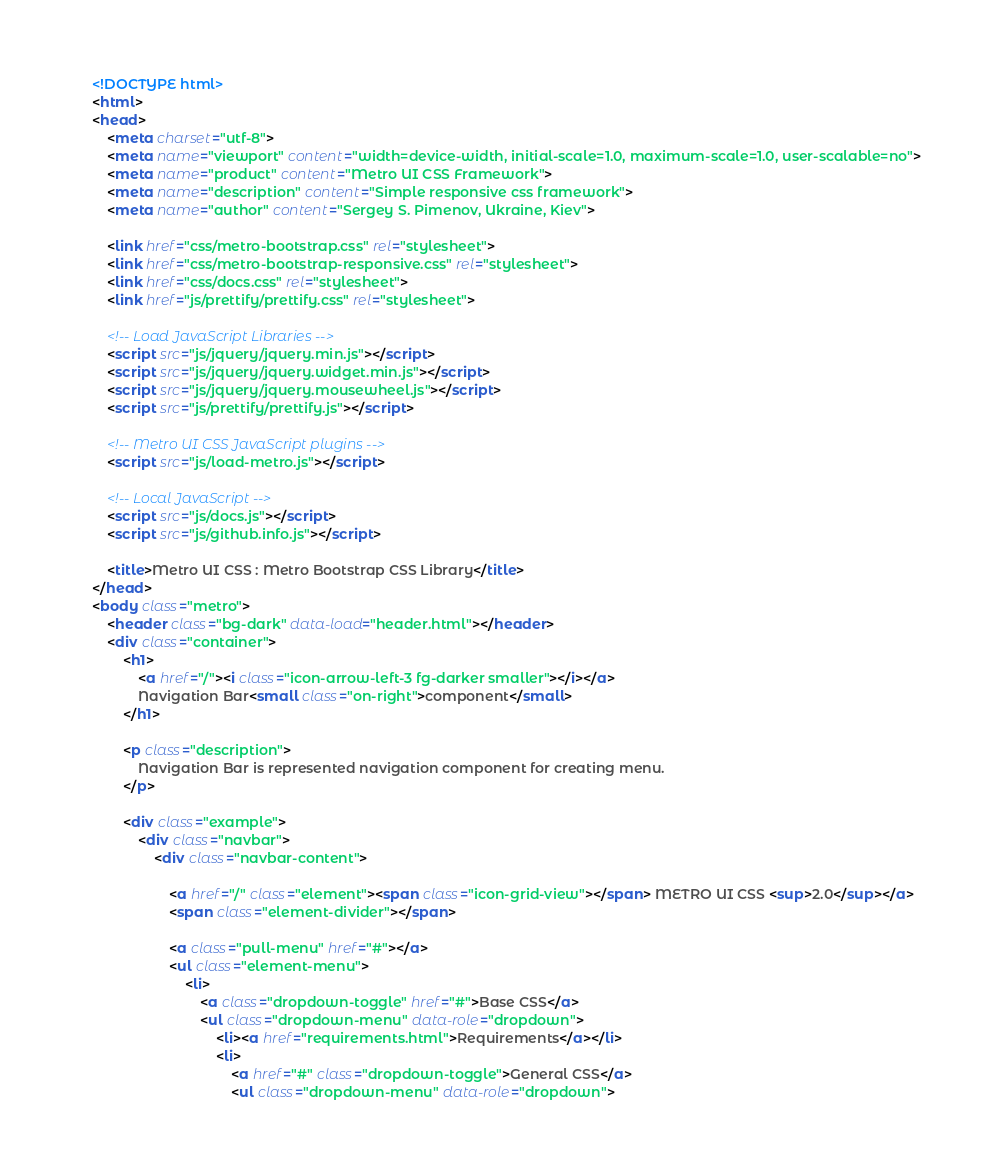<code> <loc_0><loc_0><loc_500><loc_500><_HTML_><!DOCTYPE html>
<html>
<head>
    <meta charset="utf-8">
    <meta name="viewport" content="width=device-width, initial-scale=1.0, maximum-scale=1.0, user-scalable=no">
    <meta name="product" content="Metro UI CSS Framework">
    <meta name="description" content="Simple responsive css framework">
    <meta name="author" content="Sergey S. Pimenov, Ukraine, Kiev">

    <link href="css/metro-bootstrap.css" rel="stylesheet">
    <link href="css/metro-bootstrap-responsive.css" rel="stylesheet">
    <link href="css/docs.css" rel="stylesheet">
    <link href="js/prettify/prettify.css" rel="stylesheet">

    <!-- Load JavaScript Libraries -->
    <script src="js/jquery/jquery.min.js"></script>
    <script src="js/jquery/jquery.widget.min.js"></script>
    <script src="js/jquery/jquery.mousewheel.js"></script>
    <script src="js/prettify/prettify.js"></script>

    <!-- Metro UI CSS JavaScript plugins -->
    <script src="js/load-metro.js"></script>

    <!-- Local JavaScript -->
    <script src="js/docs.js"></script>
    <script src="js/github.info.js"></script>

    <title>Metro UI CSS : Metro Bootstrap CSS Library</title>
</head>
<body class="metro">
    <header class="bg-dark" data-load="header.html"></header>
    <div class="container">
        <h1>
            <a href="/"><i class="icon-arrow-left-3 fg-darker smaller"></i></a>
            Navigation Bar<small class="on-right">component</small>
        </h1>

        <p class="description">
            Navigation Bar is represented navigation component for creating menu.
        </p>

        <div class="example">
            <div class="navbar">
                <div class="navbar-content">

                    <a href="/" class="element"><span class="icon-grid-view"></span> METRO UI CSS <sup>2.0</sup></a>
                    <span class="element-divider"></span>

                    <a class="pull-menu" href="#"></a>
                    <ul class="element-menu">
                        <li>
                            <a class="dropdown-toggle" href="#">Base CSS</a>
                            <ul class="dropdown-menu" data-role="dropdown">
                                <li><a href="requirements.html">Requirements</a></li>
                                <li>
                                    <a href="#" class="dropdown-toggle">General CSS</a>
                                    <ul class="dropdown-menu" data-role="dropdown"></code> 